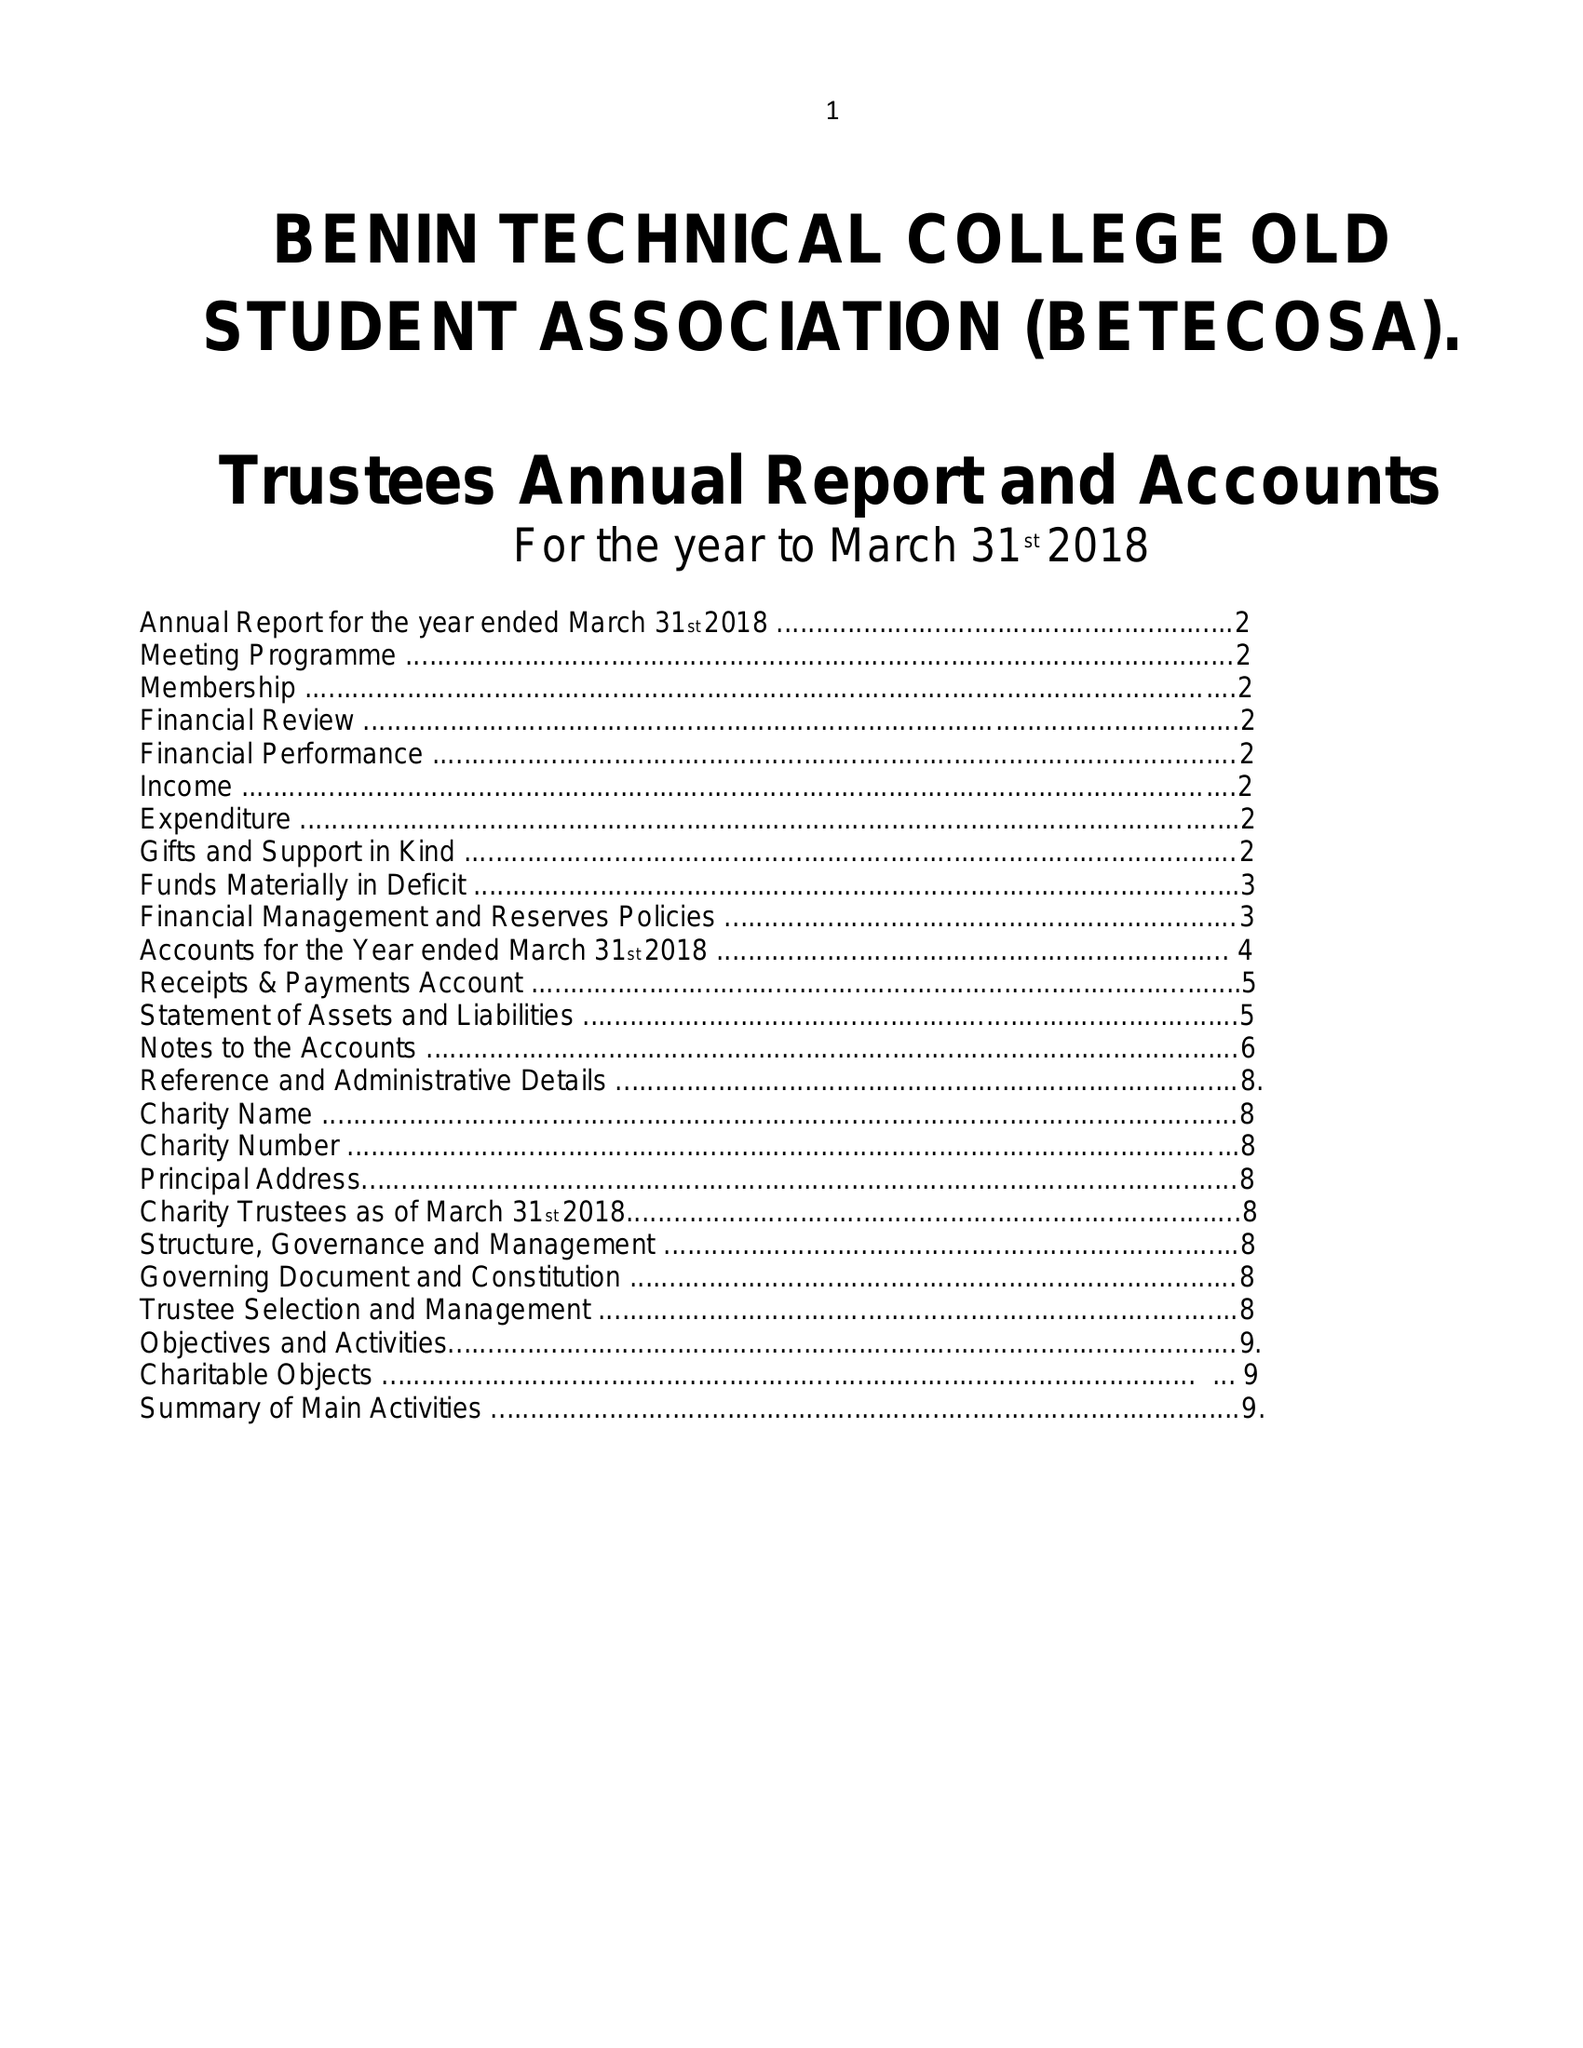What is the value for the address__street_line?
Answer the question using a single word or phrase. 16 VINEYARD CLOSE 